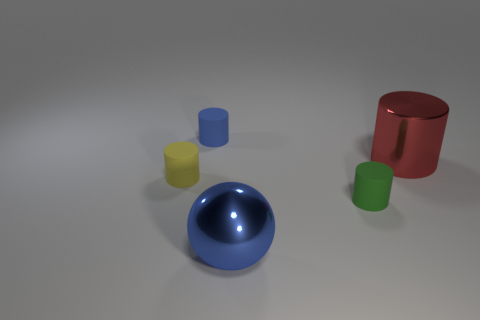Are there fewer small green cylinders that are in front of the green thing than small rubber objects that are on the right side of the large blue shiny ball?
Your response must be concise. Yes. Are there any red shiny cylinders behind the small blue matte thing?
Offer a very short reply. No. How many things are either big metal objects that are in front of the shiny cylinder or matte cylinders that are behind the green cylinder?
Keep it short and to the point. 3. What number of blocks are the same color as the large metal sphere?
Keep it short and to the point. 0. There is a large object that is the same shape as the small blue thing; what color is it?
Keep it short and to the point. Red. There is a tiny object that is both in front of the red metallic cylinder and on the left side of the small green thing; what shape is it?
Provide a succinct answer. Cylinder. Is the number of large purple shiny objects greater than the number of metallic cylinders?
Your answer should be compact. No. What is the yellow thing made of?
Provide a short and direct response. Rubber. Are there any other things that have the same size as the red metal cylinder?
Make the answer very short. Yes. There is a blue thing that is the same shape as the tiny green thing; what size is it?
Your answer should be very brief. Small. 